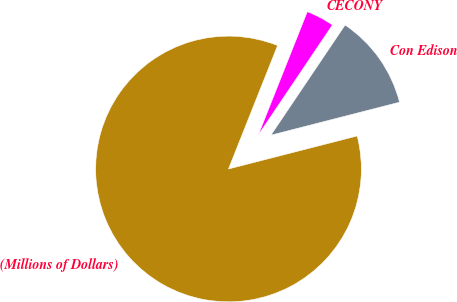Convert chart to OTSL. <chart><loc_0><loc_0><loc_500><loc_500><pie_chart><fcel>(Millions of Dollars)<fcel>Con Edison<fcel>CECONY<nl><fcel>85.01%<fcel>11.57%<fcel>3.41%<nl></chart> 